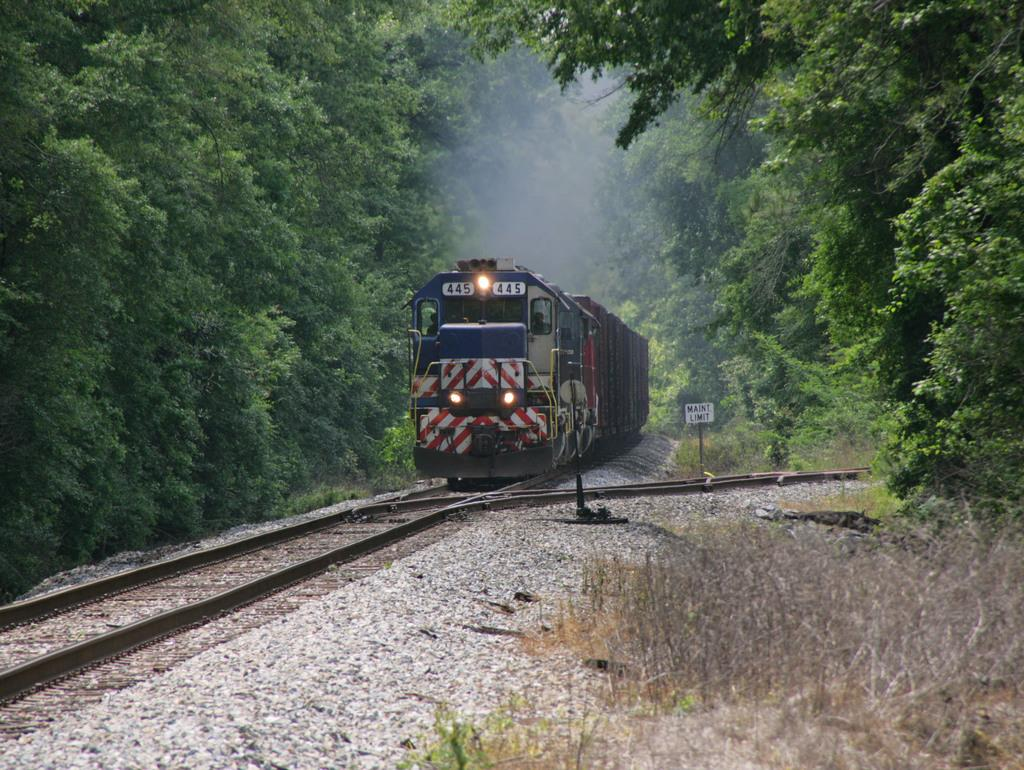What is the main subject of the image? The main subject of the image is a train. Where is the train located in the image? The train is on a track. What type of vegetation can be seen in the image? There is grass visible in the image. What other objects can be seen in the image besides the train? Stones, a board, poles, and trees are present in the image. What can be seen coming out of the train in the image? There is smoke visible in the image. What type of key is used to unlock the train in the image? There is no key present in the image, and trains are not typically unlocked with keys. Can you see the head of the train driver in the image? There is no person visible in the image, so it is not possible to see the head of the train driver. 